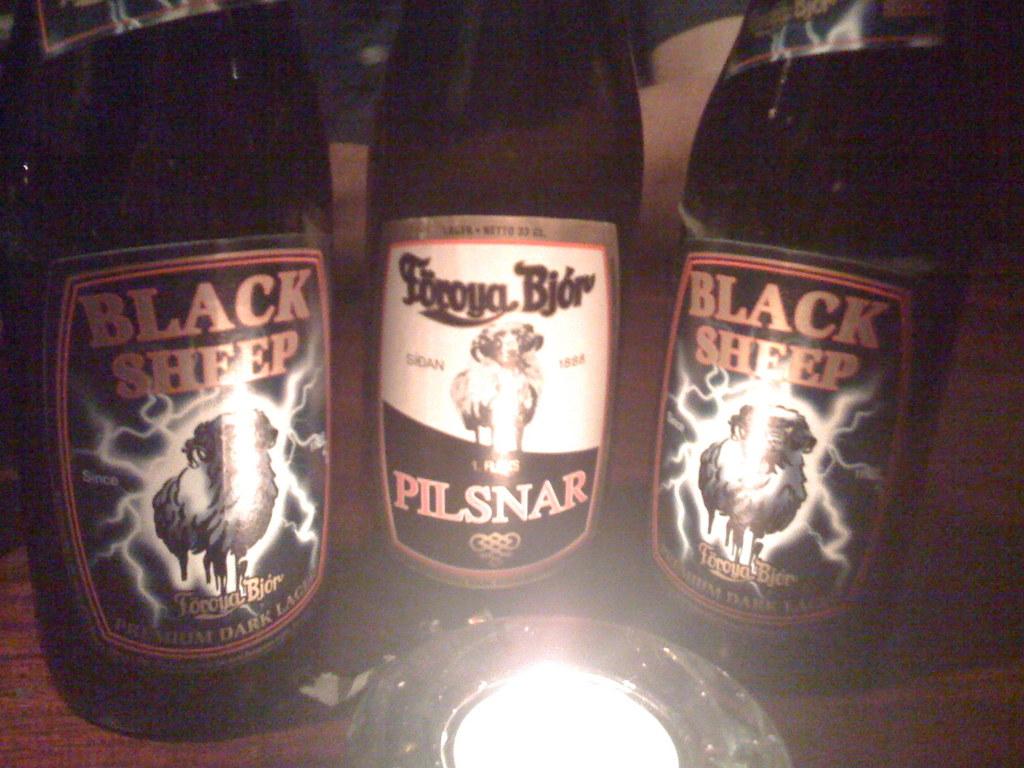What brand is the beer on the left?
Your answer should be very brief. Black sheep. What is the brand of beer in the middle?
Your response must be concise. Pilsnar. 